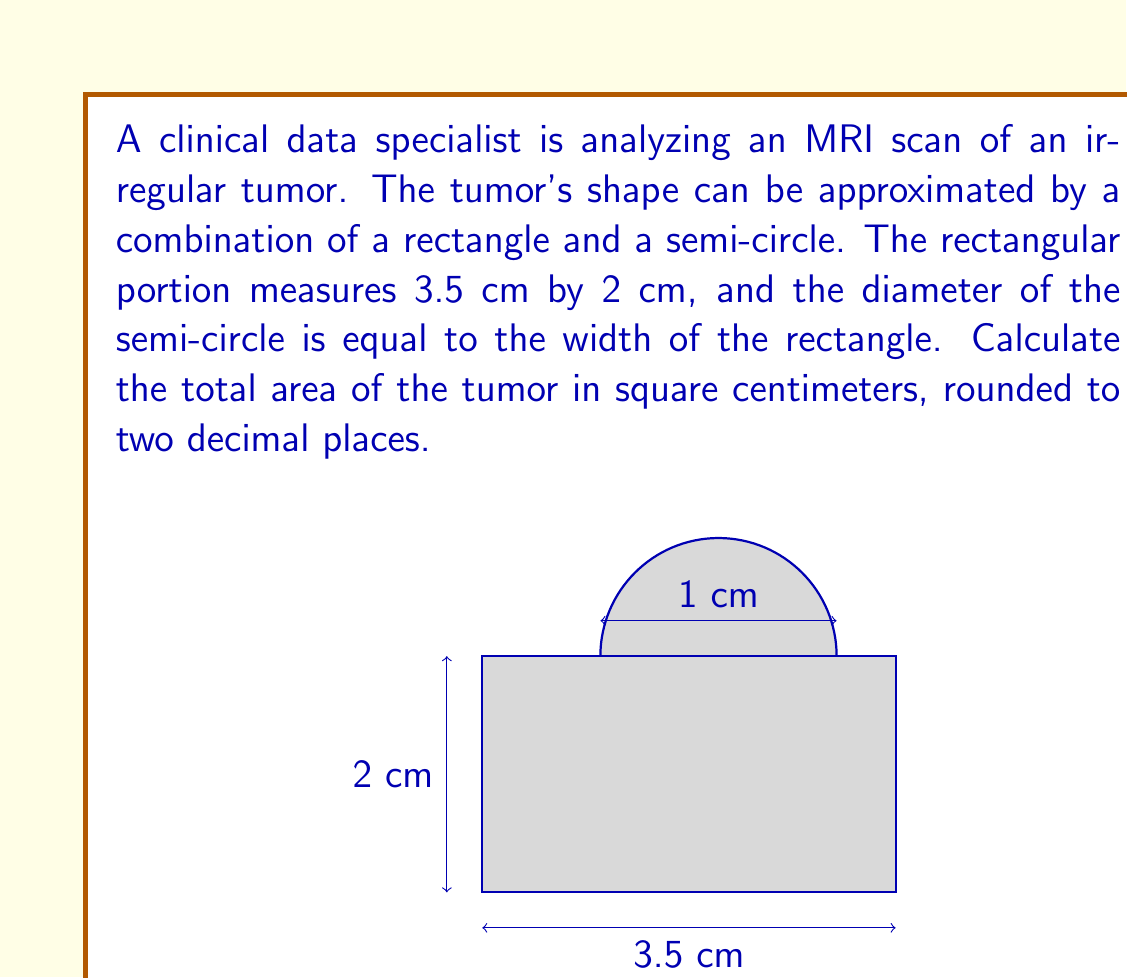Provide a solution to this math problem. To calculate the total area of the tumor, we need to find the sum of the areas of the rectangle and the semi-circle.

1. Area of the rectangle:
   $A_r = l \times w$
   $A_r = 3.5 \text{ cm} \times 2 \text{ cm} = 7 \text{ cm}^2$

2. Area of the semi-circle:
   The diameter of the semi-circle is equal to the width of the rectangle, which is 2 cm.
   Therefore, the radius is 1 cm.
   
   Area of a full circle: $A_c = \pi r^2$
   Area of a semi-circle: $A_s = \frac{1}{2} \pi r^2$
   
   $A_s = \frac{1}{2} \pi (1 \text{ cm})^2 = \frac{1}{2} \pi \text{ cm}^2$

3. Total area of the tumor:
   $A_{\text{total}} = A_r + A_s$
   $A_{\text{total}} = 7 \text{ cm}^2 + \frac{1}{2} \pi \text{ cm}^2$
   $A_{\text{total}} = 7 + \frac{1}{2} \pi \text{ cm}^2$
   $A_{\text{total}} \approx 8.57 \text{ cm}^2$

Rounding to two decimal places, we get 8.57 cm².
Answer: 8.57 cm² 